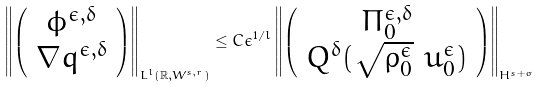Convert formula to latex. <formula><loc_0><loc_0><loc_500><loc_500>\left \| \left ( \begin{array} { c } \phi ^ { \epsilon , \delta } \\ \nabla q ^ { \epsilon , \delta } \end{array} \right ) \right \| _ { L ^ { l } ( \mathbb { R } , W ^ { s , r } ) } \leq C \epsilon ^ { 1 / l } \left \| \left ( \begin{array} { c } \Pi ^ { \epsilon , \delta } _ { 0 } \\ Q ^ { \delta } ( \sqrt { \rho ^ { \epsilon } _ { 0 } } \ u ^ { \epsilon } _ { 0 } ) \end{array} \right ) \right \| _ { H ^ { s + \sigma } }</formula> 